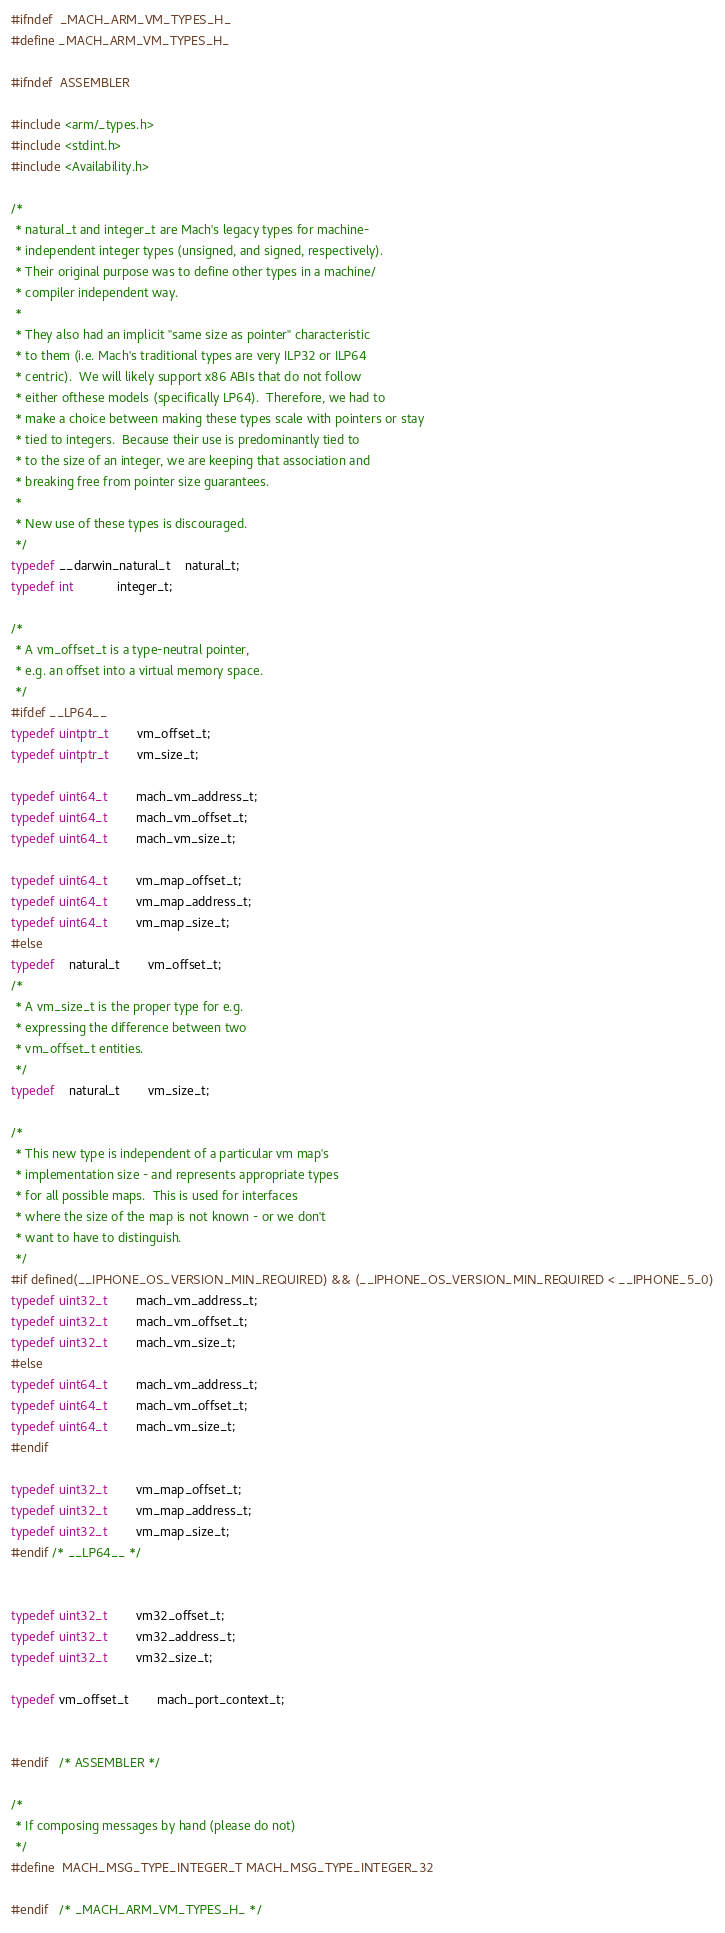Convert code to text. <code><loc_0><loc_0><loc_500><loc_500><_C_>#ifndef	_MACH_ARM_VM_TYPES_H_
#define _MACH_ARM_VM_TYPES_H_

#ifndef	ASSEMBLER

#include <arm/_types.h>
#include <stdint.h>
#include <Availability.h>

/*
 * natural_t and integer_t are Mach's legacy types for machine-
 * independent integer types (unsigned, and signed, respectively).
 * Their original purpose was to define other types in a machine/
 * compiler independent way.
 *
 * They also had an implicit "same size as pointer" characteristic
 * to them (i.e. Mach's traditional types are very ILP32 or ILP64
 * centric).  We will likely support x86 ABIs that do not follow
 * either ofthese models (specifically LP64).  Therefore, we had to
 * make a choice between making these types scale with pointers or stay
 * tied to integers.  Because their use is predominantly tied to
 * to the size of an integer, we are keeping that association and
 * breaking free from pointer size guarantees.
 *
 * New use of these types is discouraged.
 */
typedef __darwin_natural_t	natural_t;
typedef int			integer_t;

/*
 * A vm_offset_t is a type-neutral pointer,
 * e.g. an offset into a virtual memory space.
 */
#ifdef __LP64__
typedef uintptr_t		vm_offset_t;
typedef uintptr_t		vm_size_t;

typedef uint64_t		mach_vm_address_t;
typedef uint64_t		mach_vm_offset_t;
typedef uint64_t		mach_vm_size_t;

typedef uint64_t		vm_map_offset_t;
typedef uint64_t		vm_map_address_t;
typedef uint64_t		vm_map_size_t;
#else
typedef	natural_t		vm_offset_t;
/*
 * A vm_size_t is the proper type for e.g.
 * expressing the difference between two
 * vm_offset_t entities.
 */
typedef	natural_t		vm_size_t;

/*
 * This new type is independent of a particular vm map's
 * implementation size - and represents appropriate types
 * for all possible maps.  This is used for interfaces
 * where the size of the map is not known - or we don't
 * want to have to distinguish.
 */
#if defined(__IPHONE_OS_VERSION_MIN_REQUIRED) && (__IPHONE_OS_VERSION_MIN_REQUIRED < __IPHONE_5_0)
typedef uint32_t		mach_vm_address_t;
typedef uint32_t		mach_vm_offset_t;
typedef uint32_t		mach_vm_size_t;
#else
typedef uint64_t		mach_vm_address_t;
typedef uint64_t		mach_vm_offset_t;
typedef uint64_t		mach_vm_size_t;
#endif

typedef uint32_t		vm_map_offset_t;
typedef uint32_t		vm_map_address_t;
typedef uint32_t		vm_map_size_t;
#endif /* __LP64__ */


typedef uint32_t		vm32_offset_t;
typedef uint32_t		vm32_address_t;
typedef uint32_t		vm32_size_t;

typedef vm_offset_t		mach_port_context_t;


#endif	/* ASSEMBLER */

/*
 * If composing messages by hand (please do not)
 */
#define	MACH_MSG_TYPE_INTEGER_T	MACH_MSG_TYPE_INTEGER_32

#endif	/* _MACH_ARM_VM_TYPES_H_ */
</code> 